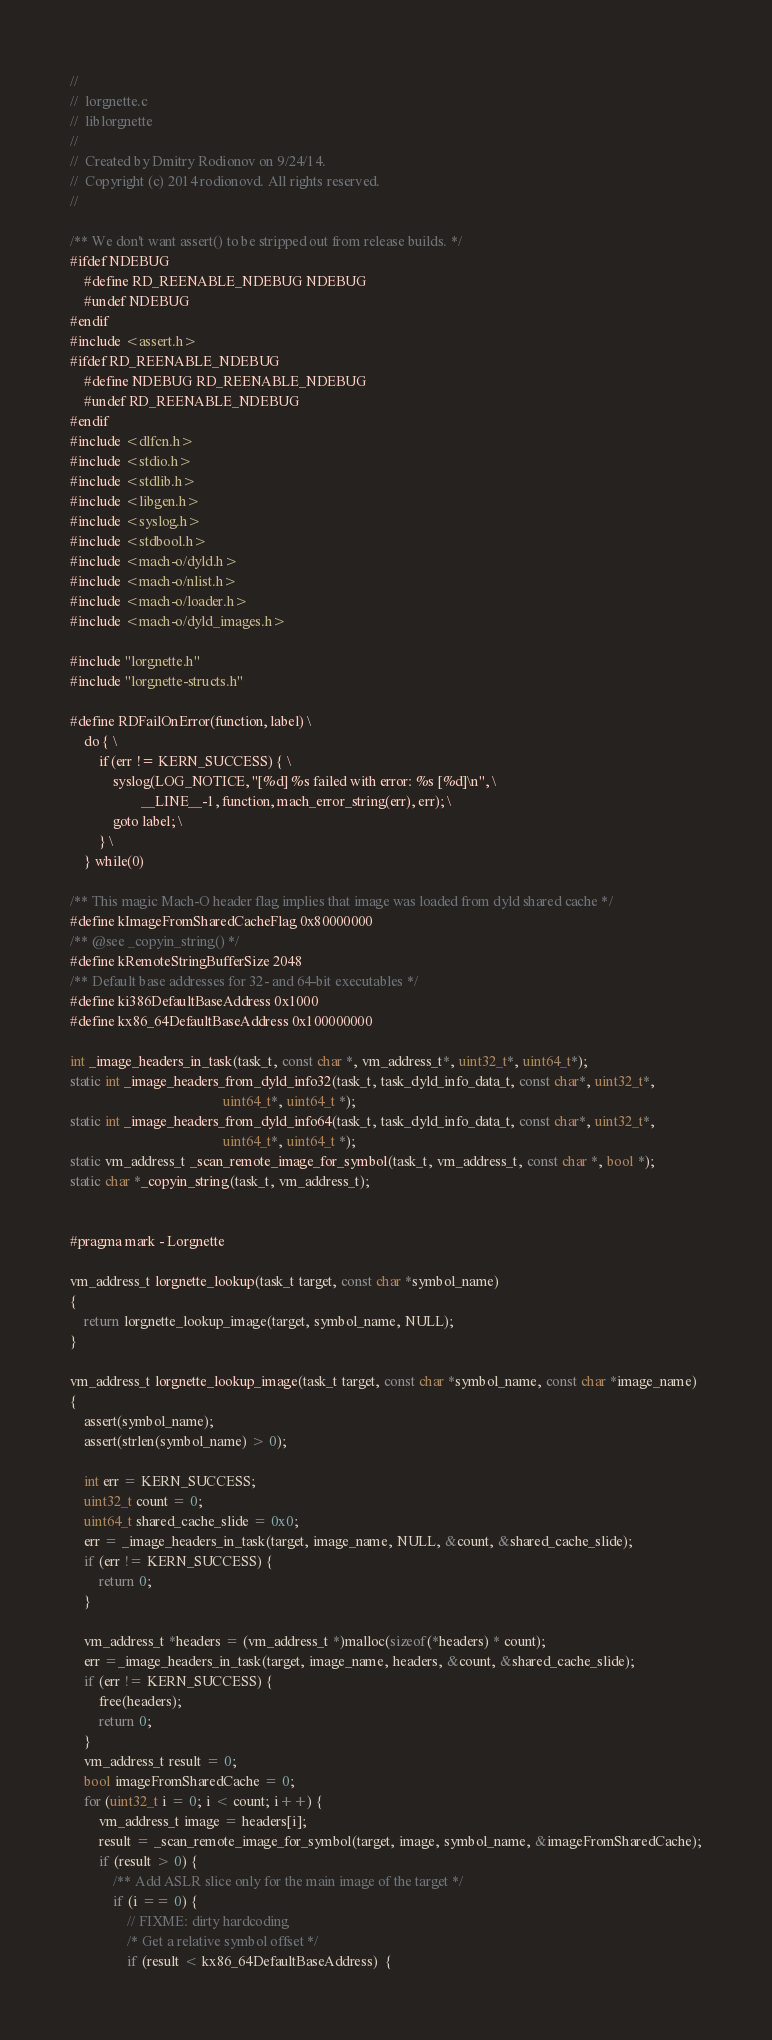Convert code to text. <code><loc_0><loc_0><loc_500><loc_500><_ObjectiveC_>//
//  lorgnette.c
//  liblorgnette
//
//  Created by Dmitry Rodionov on 9/24/14.
//  Copyright (c) 2014 rodionovd. All rights reserved.
//

/** We don't want assert() to be stripped out from release builds. */
#ifdef NDEBUG
	#define RD_REENABLE_NDEBUG NDEBUG
	#undef NDEBUG
#endif
#include <assert.h>
#ifdef RD_REENABLE_NDEBUG
	#define NDEBUG RD_REENABLE_NDEBUG
	#undef RD_REENABLE_NDEBUG
#endif
#include <dlfcn.h>
#include <stdio.h>
#include <stdlib.h>
#include <libgen.h>
#include <syslog.h>
#include <stdbool.h>
#include <mach-o/dyld.h>
#include <mach-o/nlist.h>
#include <mach-o/loader.h>
#include <mach-o/dyld_images.h>

#include "lorgnette.h"
#include "lorgnette-structs.h"

#define RDFailOnError(function, label) \
	do { \
		if (err != KERN_SUCCESS) { \
			syslog(LOG_NOTICE, "[%d] %s failed with error: %s [%d]\n", \
					__LINE__-1, function, mach_error_string(err), err); \
			goto label; \
		} \
	} while(0)

/** This magic Mach-O header flag implies that image was loaded from dyld shared cache */
#define kImageFromSharedCacheFlag 0x80000000
/** @see _copyin_string() */
#define kRemoteStringBufferSize 2048
/** Default base addresses for 32- and 64-bit executables */
#define ki386DefaultBaseAddress 0x1000
#define kx86_64DefaultBaseAddress 0x100000000

int _image_headers_in_task(task_t, const char *, vm_address_t*, uint32_t*, uint64_t*);
static int _image_headers_from_dyld_info32(task_t, task_dyld_info_data_t, const char*, uint32_t*,
										   uint64_t*, uint64_t *);
static int _image_headers_from_dyld_info64(task_t, task_dyld_info_data_t, const char*, uint32_t*,
										   uint64_t*, uint64_t *);
static vm_address_t _scan_remote_image_for_symbol(task_t, vm_address_t, const char *, bool *);
static char *_copyin_string(task_t, vm_address_t);


#pragma mark - Lorgnette

vm_address_t lorgnette_lookup(task_t target, const char *symbol_name)
{
	return lorgnette_lookup_image(target, symbol_name, NULL);
}

vm_address_t lorgnette_lookup_image(task_t target, const char *symbol_name, const char *image_name)
{
	assert(symbol_name);
	assert(strlen(symbol_name) > 0);

	int err = KERN_SUCCESS;
	uint32_t count = 0;
	uint64_t shared_cache_slide = 0x0;
	err = _image_headers_in_task(target, image_name, NULL, &count, &shared_cache_slide);
	if (err != KERN_SUCCESS) {
		return 0;
	}

	vm_address_t *headers = (vm_address_t *)malloc(sizeof(*headers) * count);
	err =_image_headers_in_task(target, image_name, headers, &count, &shared_cache_slide);
	if (err != KERN_SUCCESS) {
		free(headers);
		return 0;
	}
	vm_address_t result = 0;
	bool imageFromSharedCache = 0;
	for (uint32_t i = 0; i < count; i++) {
		vm_address_t image = headers[i];
		result = _scan_remote_image_for_symbol(target, image, symbol_name, &imageFromSharedCache);
		if (result > 0) {
			/** Add ASLR slice only for the main image of the target */
			if (i == 0) {
				// FIXME: dirty hardcoding
				/* Get a relative symbol offset */
				if (result < kx86_64DefaultBaseAddress)  {</code> 